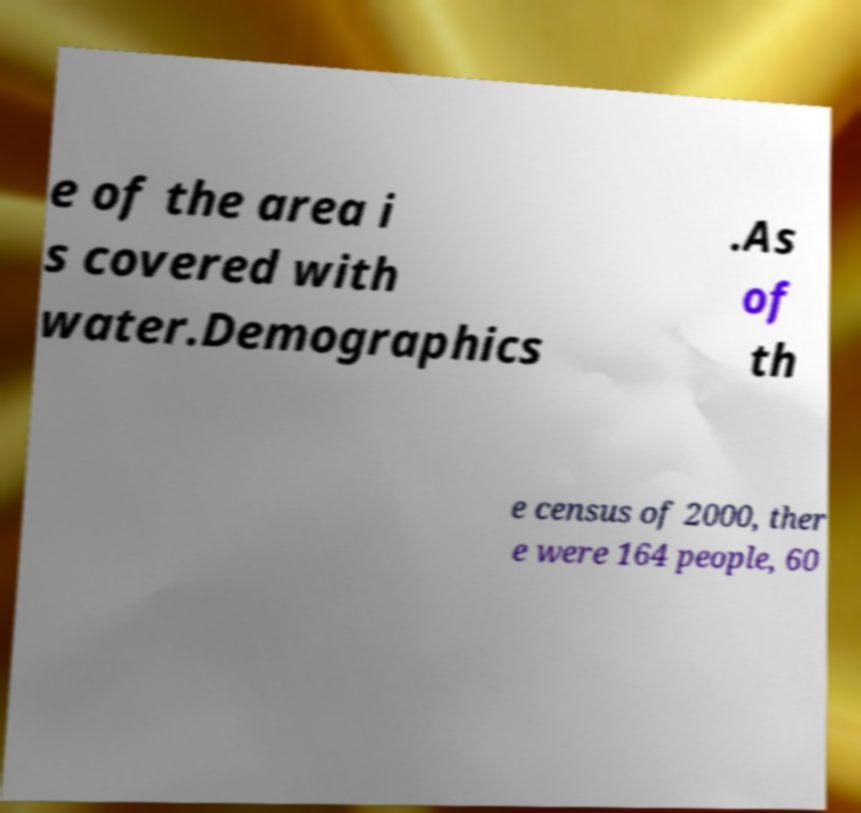Can you read and provide the text displayed in the image?This photo seems to have some interesting text. Can you extract and type it out for me? e of the area i s covered with water.Demographics .As of th e census of 2000, ther e were 164 people, 60 